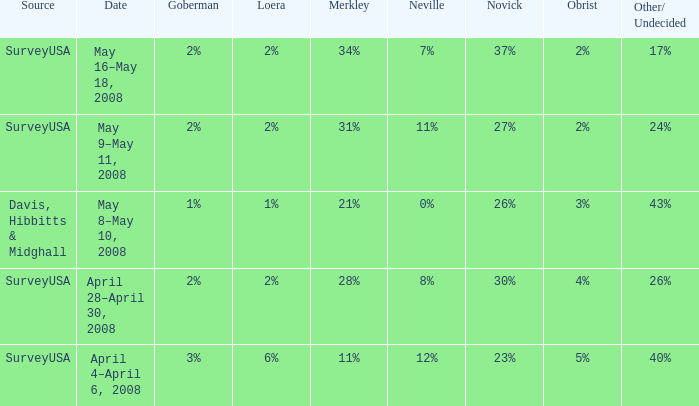Which neville has a novick rate of 23%? 12%. 